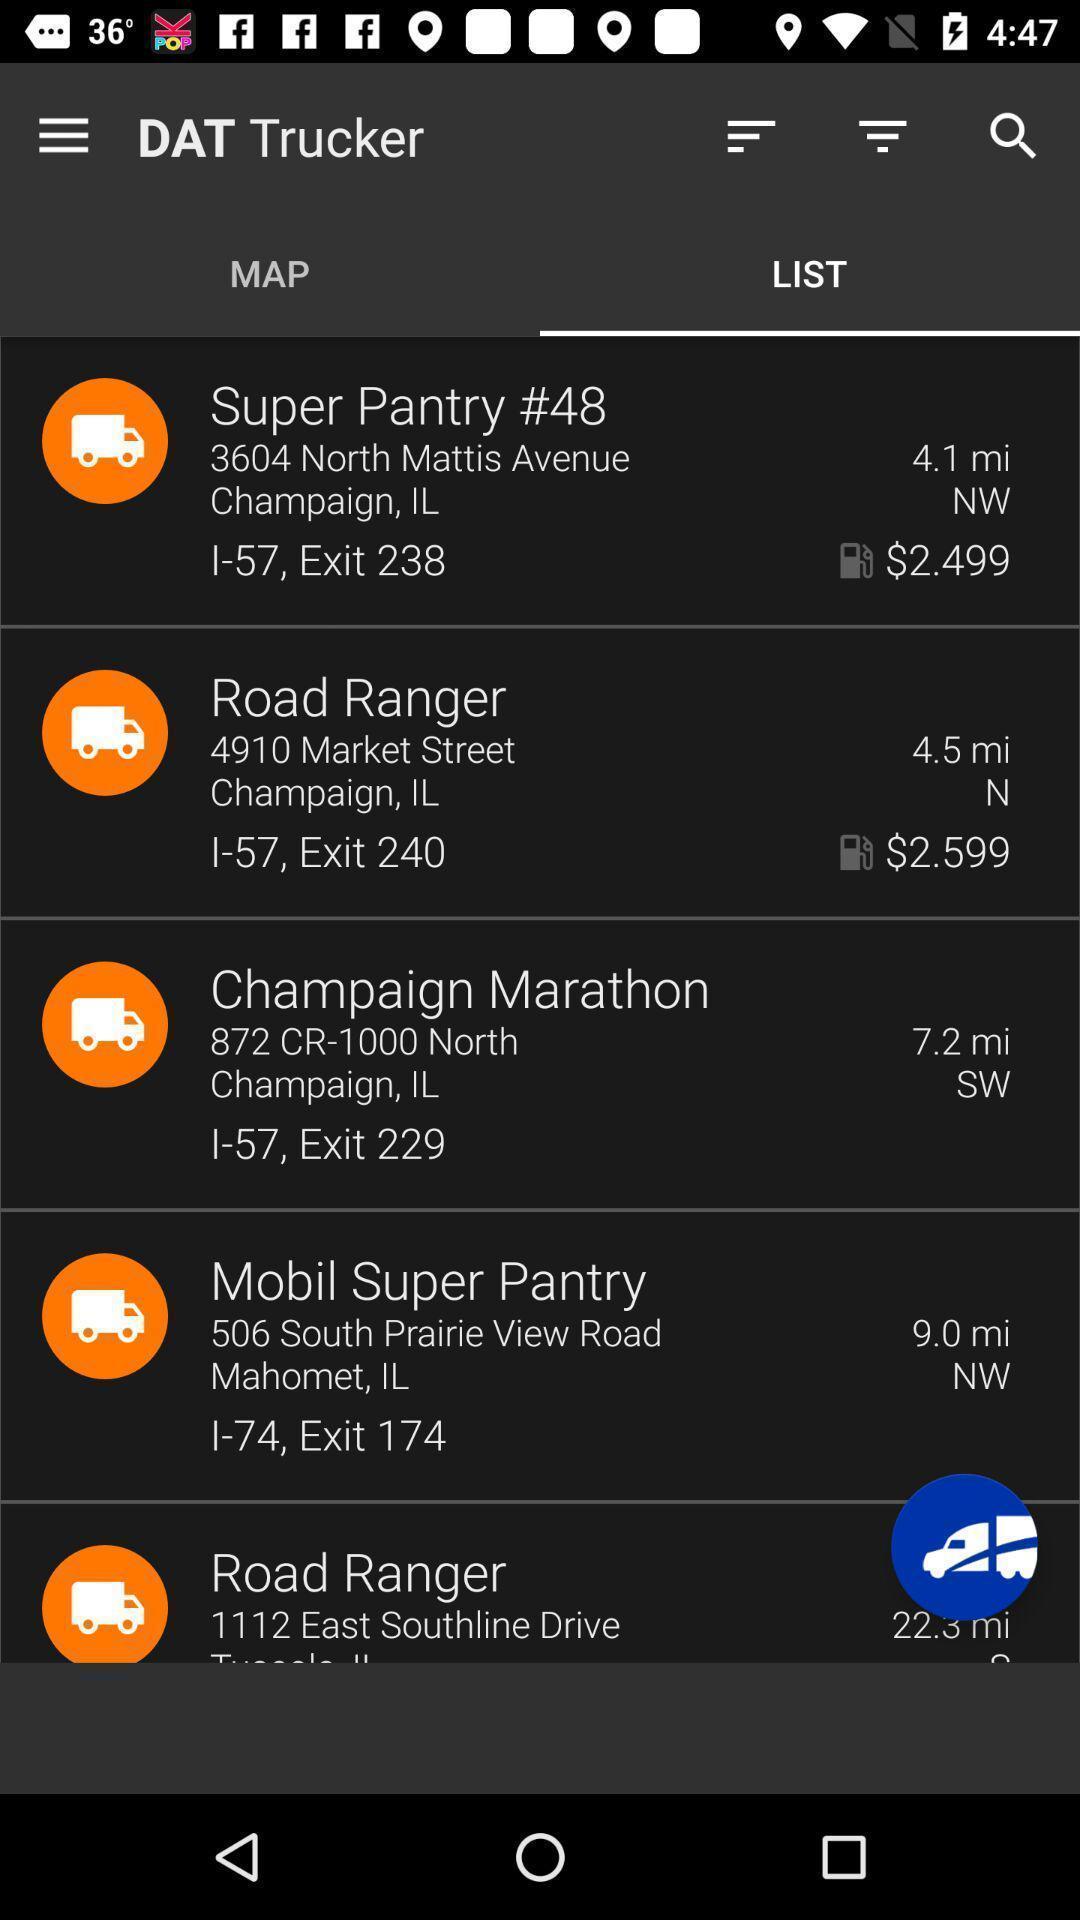Please provide a description for this image. Screen display list page of a tracker app. 